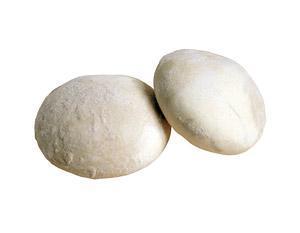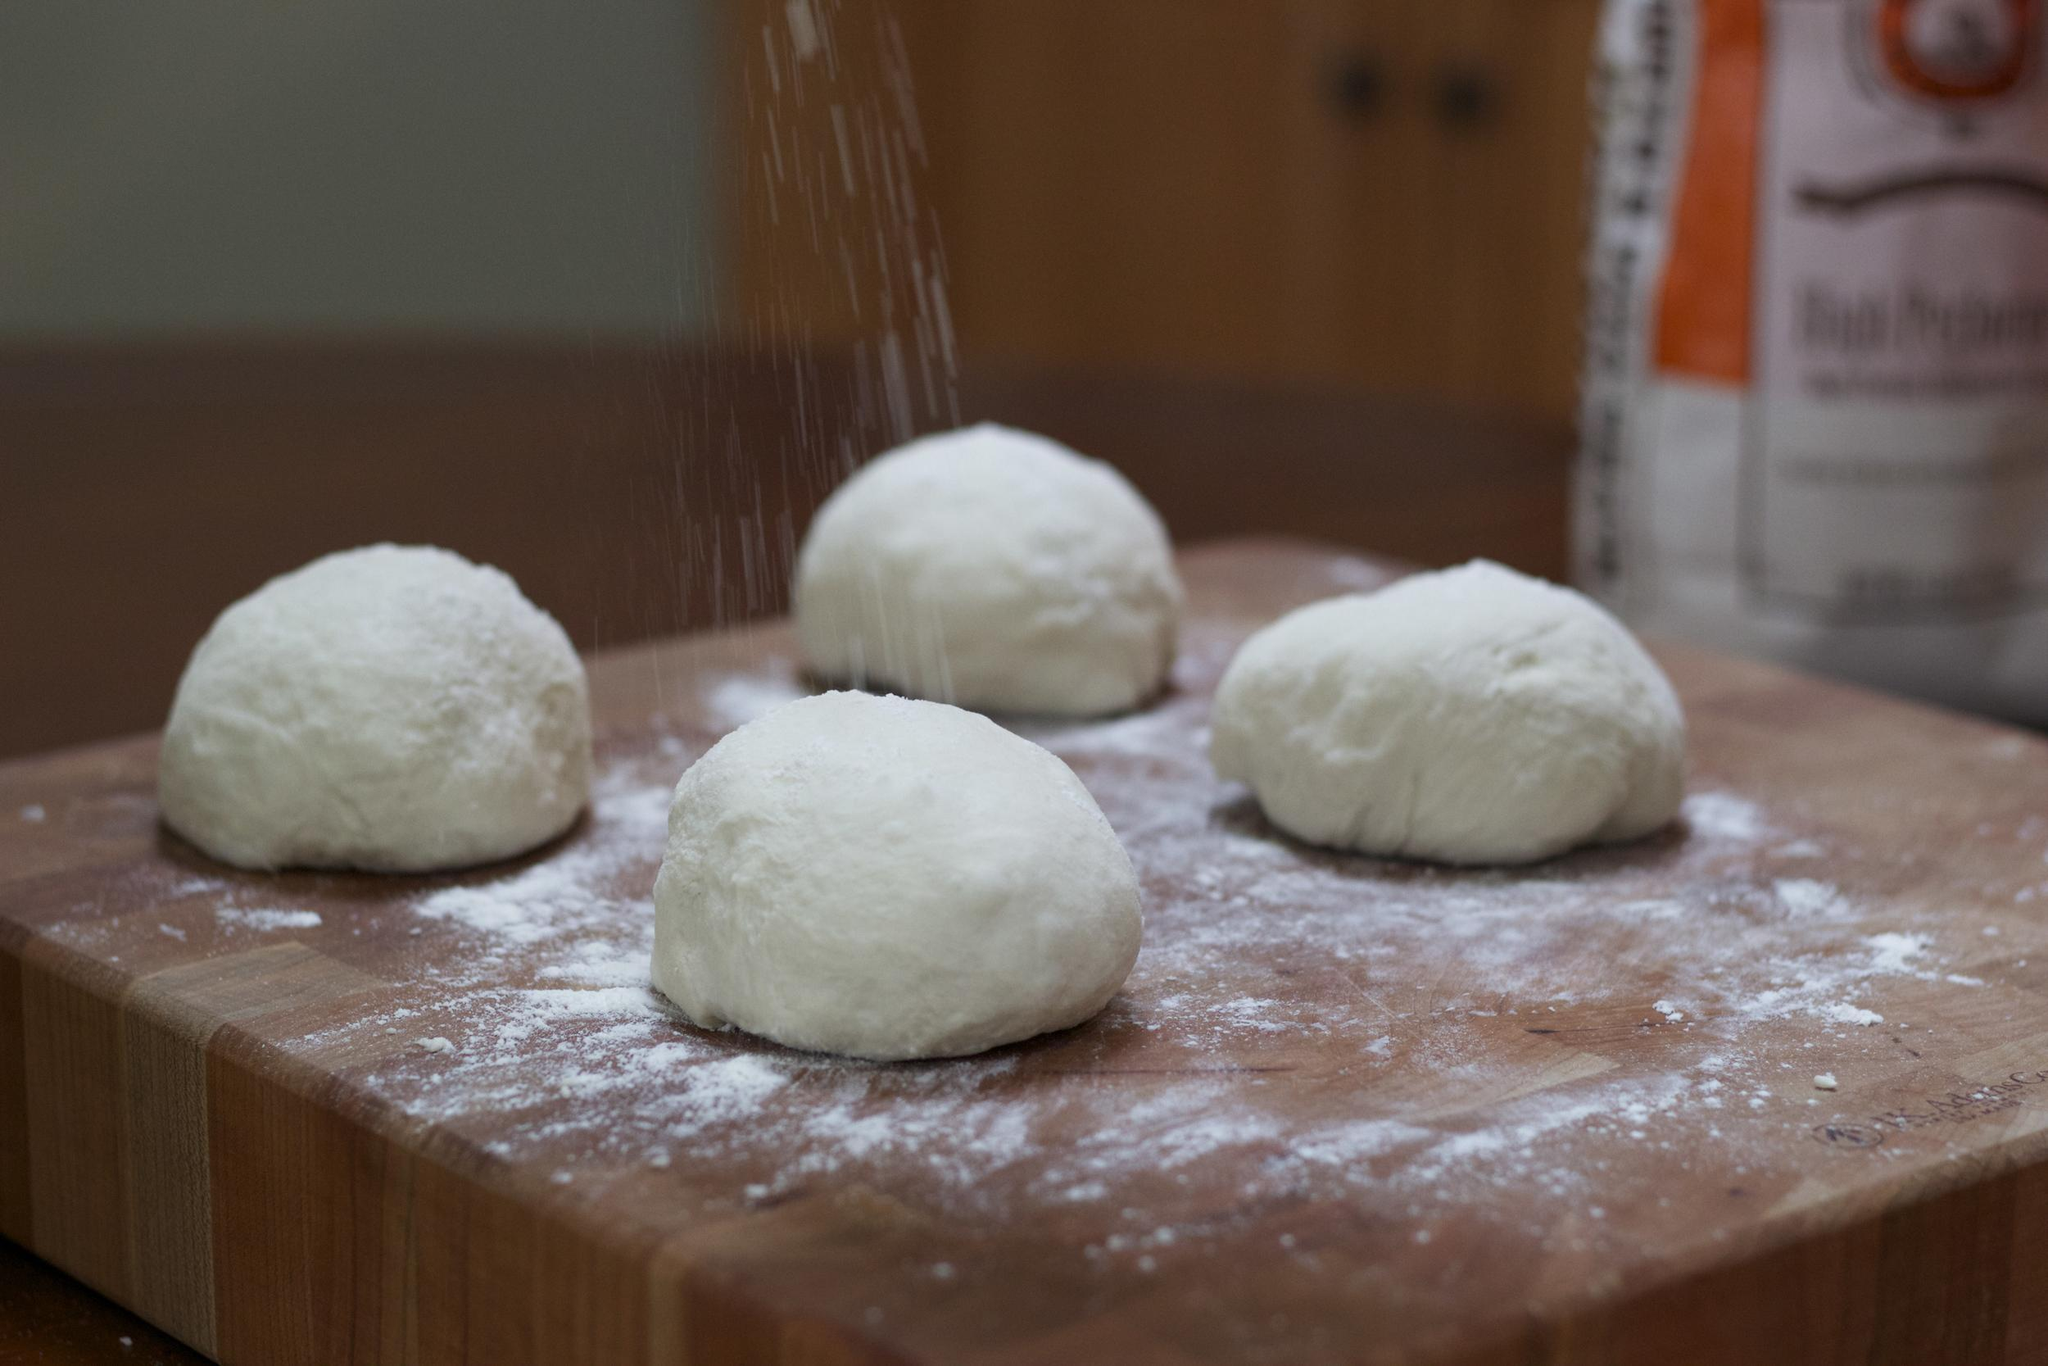The first image is the image on the left, the second image is the image on the right. Examine the images to the left and right. Is the description "There are exactly two balls of dough in one of the images." accurate? Answer yes or no. Yes. The first image is the image on the left, the second image is the image on the right. Examine the images to the left and right. Is the description "Dough is resting on a wooden surface in both pictures." accurate? Answer yes or no. No. 